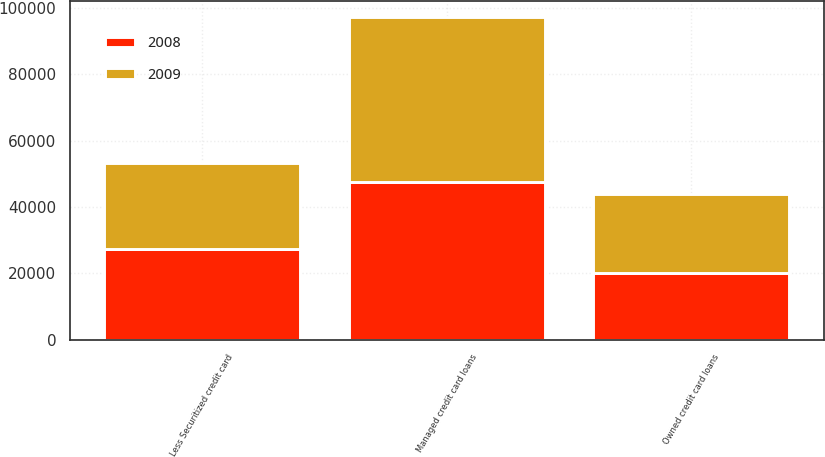Convert chart to OTSL. <chart><loc_0><loc_0><loc_500><loc_500><stacked_bar_chart><ecel><fcel>Managed credit card loans<fcel>Less Securitized credit card<fcel>Owned credit card loans<nl><fcel>2008<fcel>47465<fcel>27235<fcel>20230<nl><fcel>2009<fcel>49693<fcel>25879<fcel>23814<nl></chart> 